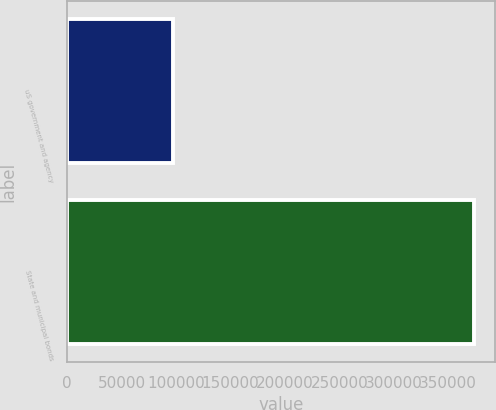Convert chart to OTSL. <chart><loc_0><loc_0><loc_500><loc_500><bar_chart><fcel>uS government and agency<fcel>State and municipal bonds<nl><fcel>96885<fcel>373998<nl></chart> 